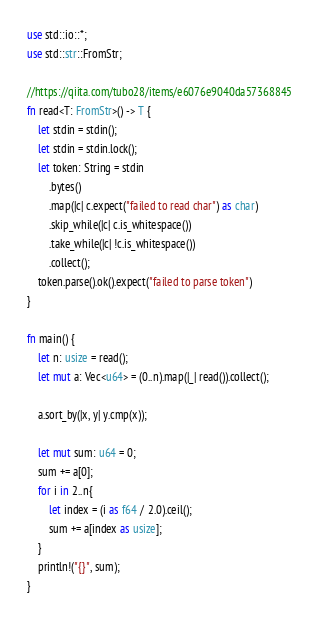Convert code to text. <code><loc_0><loc_0><loc_500><loc_500><_Rust_>use std::io::*;
use std::str::FromStr;

//https://qiita.com/tubo28/items/e6076e9040da57368845
fn read<T: FromStr>() -> T {
    let stdin = stdin();
    let stdin = stdin.lock();
    let token: String = stdin
        .bytes()
        .map(|c| c.expect("failed to read char") as char)
        .skip_while(|c| c.is_whitespace())
        .take_while(|c| !c.is_whitespace())
        .collect();
    token.parse().ok().expect("failed to parse token")
}

fn main() {
    let n: usize = read();
    let mut a: Vec<u64> = (0..n).map(|_| read()).collect();

    a.sort_by(|x, y| y.cmp(x));

    let mut sum: u64 = 0;
    sum += a[0];
    for i in 2..n{
        let index = (i as f64 / 2.0).ceil();
        sum += a[index as usize];
    }
    println!("{}", sum);
}
</code> 